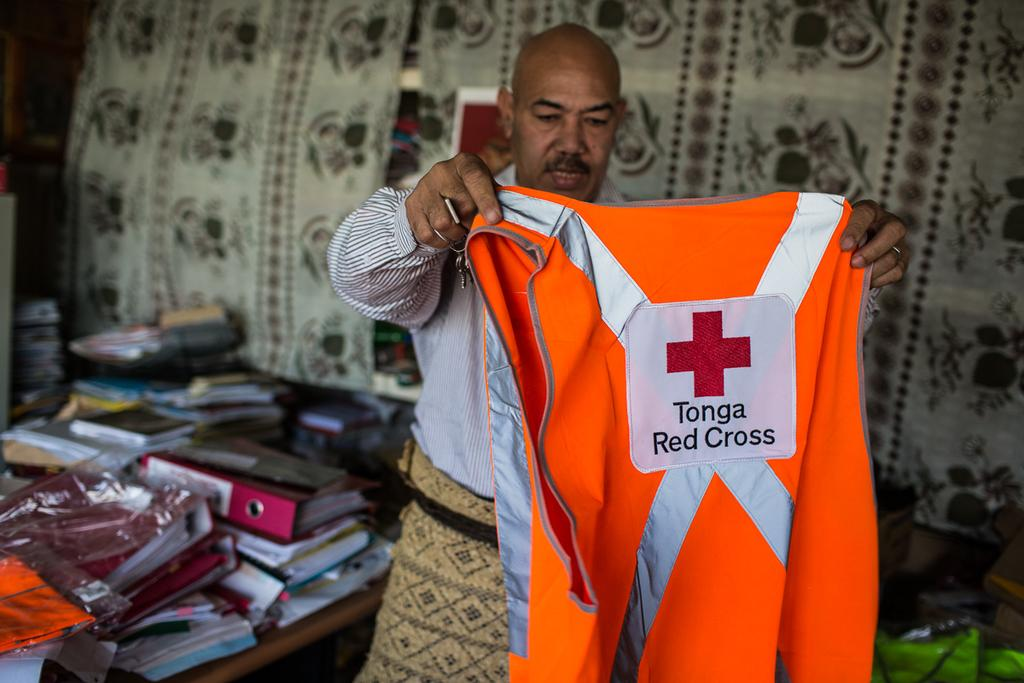<image>
Summarize the visual content of the image. a man holding up a top that says 'tonga red cross' on it 